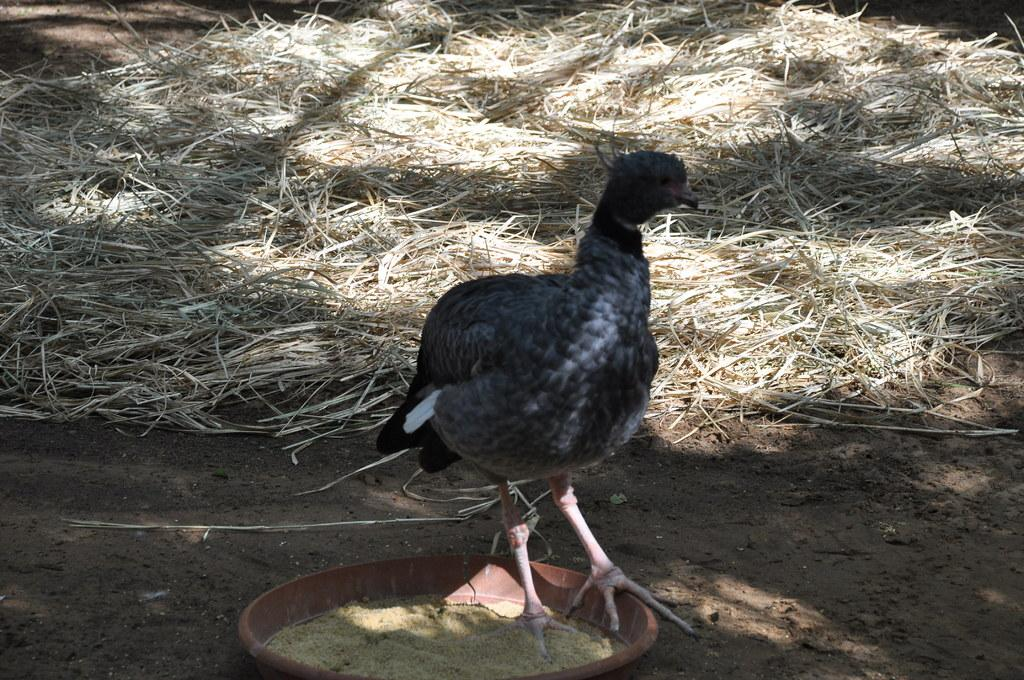What type of bird is in the center of the image? There is a rallidae in the center of the image. What is on the plate that is visible in the image? There is a plate containing food in the image. What can be seen beneath the bird and plate in the image? The ground is visible in the image. What type of vegetation is in the background of the image? There is dry grass in the background of the image. What type of knee injury is the rallidae suffering from in the image? There is no indication of a knee injury in the image; the rallidae appears to be standing normally. 